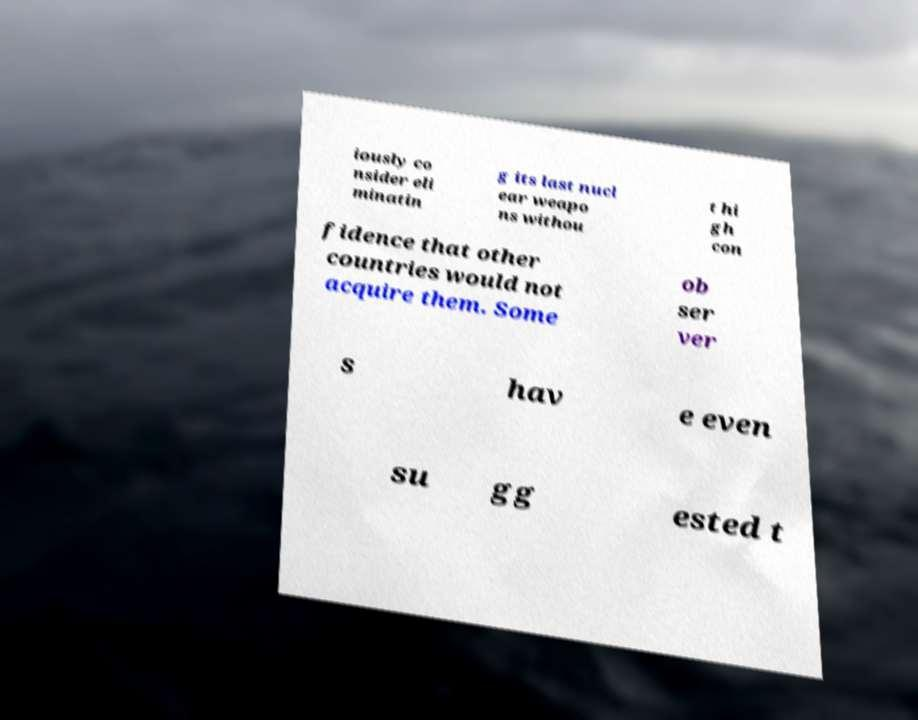What messages or text are displayed in this image? I need them in a readable, typed format. iously co nsider eli minatin g its last nucl ear weapo ns withou t hi gh con fidence that other countries would not acquire them. Some ob ser ver s hav e even su gg ested t 